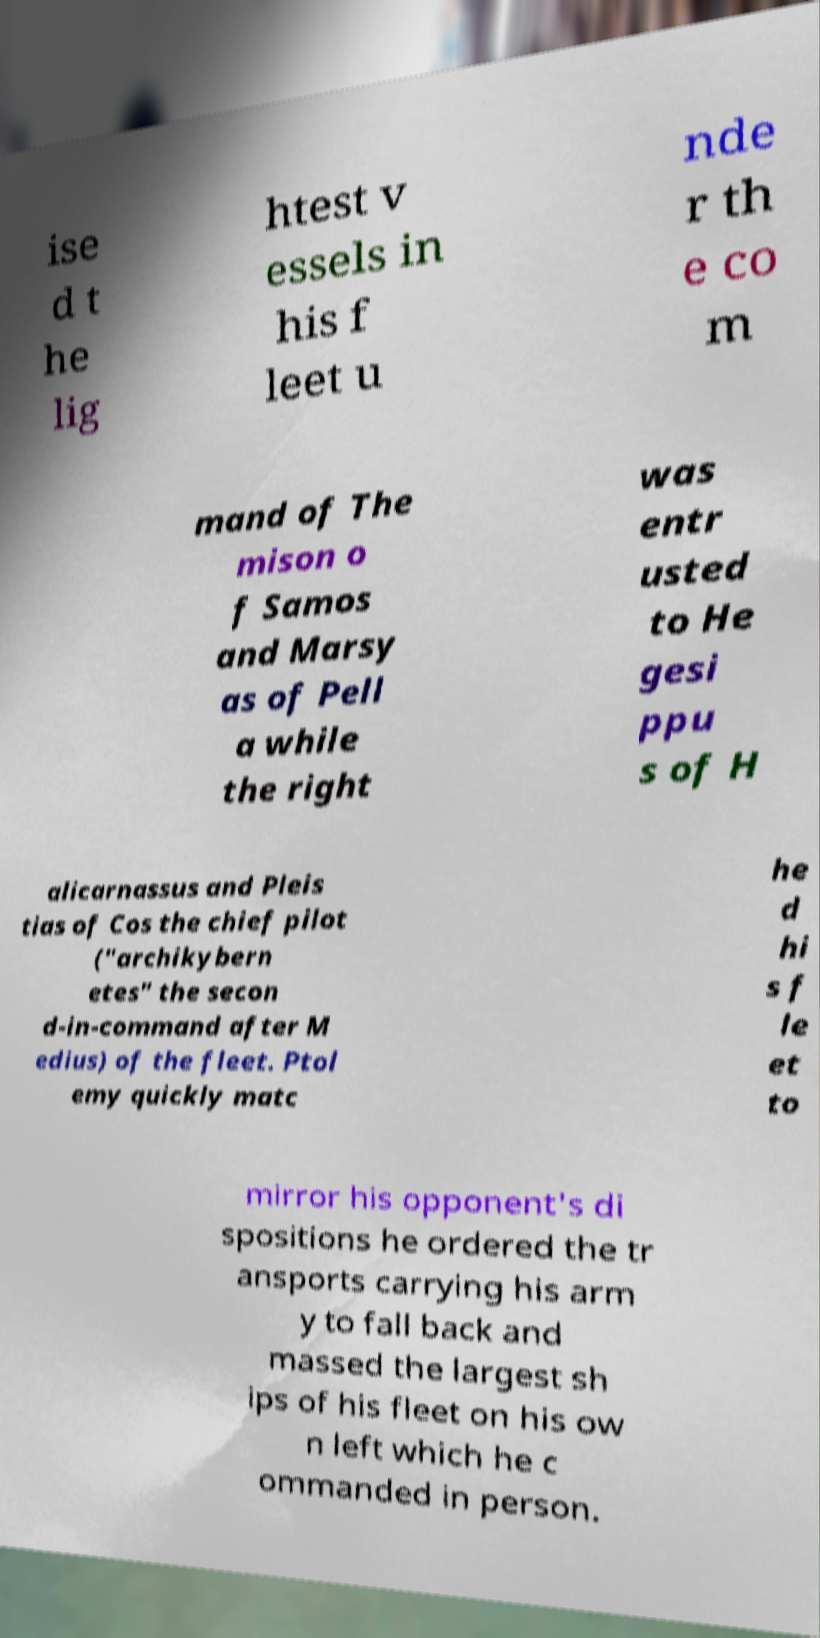Can you accurately transcribe the text from the provided image for me? ise d t he lig htest v essels in his f leet u nde r th e co m mand of The mison o f Samos and Marsy as of Pell a while the right was entr usted to He gesi ppu s of H alicarnassus and Pleis tias of Cos the chief pilot ("archikybern etes" the secon d-in-command after M edius) of the fleet. Ptol emy quickly matc he d hi s f le et to mirror his opponent's di spositions he ordered the tr ansports carrying his arm y to fall back and massed the largest sh ips of his fleet on his ow n left which he c ommanded in person. 